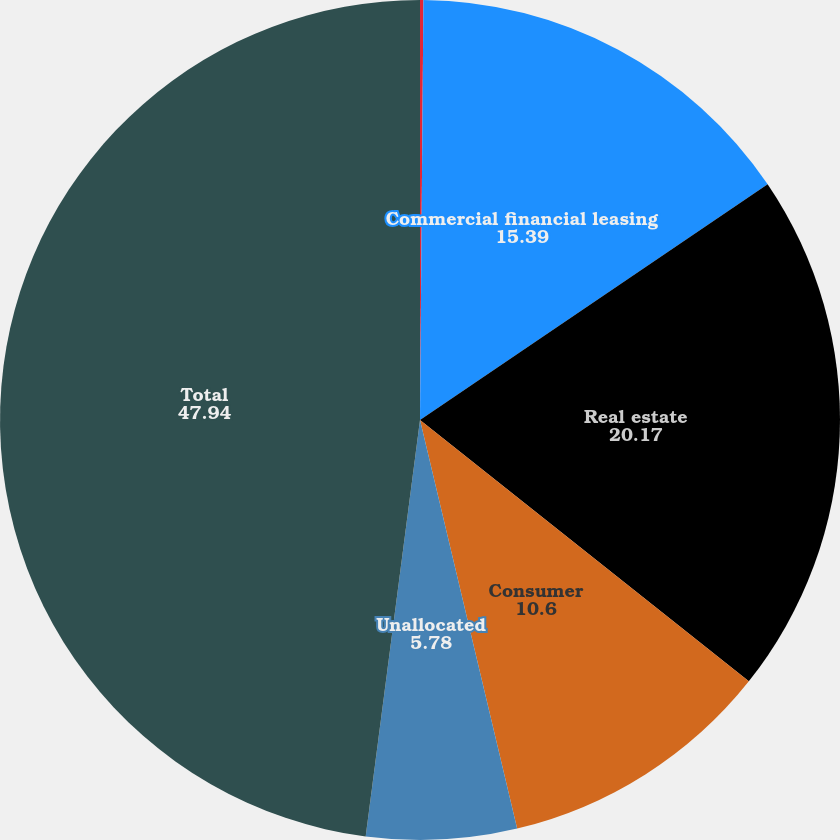Convert chart. <chart><loc_0><loc_0><loc_500><loc_500><pie_chart><fcel>December 31<fcel>Commercial financial leasing<fcel>Real estate<fcel>Consumer<fcel>Unallocated<fcel>Total<nl><fcel>0.13%<fcel>15.39%<fcel>20.17%<fcel>10.6%<fcel>5.78%<fcel>47.94%<nl></chart> 